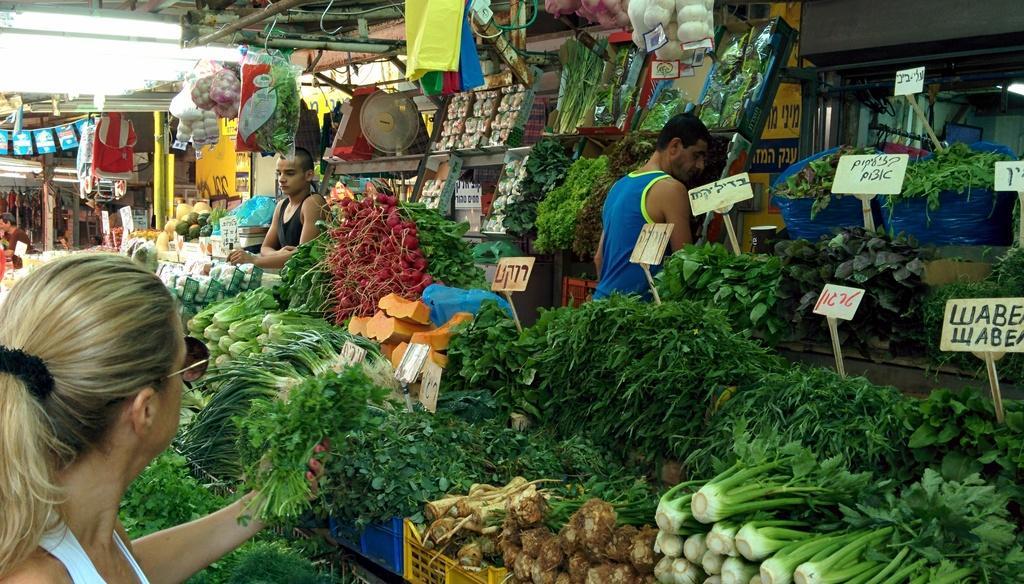Describe this image in one or two sentences. In this picture I can see there is a woman standing at left side and she is holding a coriander leafs in her hand and there are few other vegetables and green leafy vegetables placed here. There are some onions, garlic packed in packets and there is a man standing in between the vegetables and there is a boy standing on to left. There are lights attached to the ceiling. 